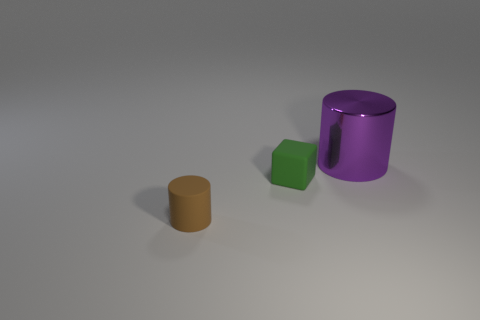Are there any other things that are the same shape as the tiny green rubber object?
Ensure brevity in your answer.  No. What shape is the shiny object that is on the right side of the matte object that is in front of the small object that is behind the rubber cylinder?
Your response must be concise. Cylinder. What is the color of the cylinder in front of the big metal thing?
Offer a terse response. Brown. How many things are objects behind the brown cylinder or cylinders right of the small cube?
Your response must be concise. 2. What number of shiny objects are the same shape as the small brown matte thing?
Your answer should be very brief. 1. There is a cube that is the same size as the matte cylinder; what color is it?
Your response must be concise. Green. The cylinder behind the matte thing to the left of the green matte thing right of the tiny cylinder is what color?
Offer a very short reply. Purple. Is the size of the green matte cube the same as the purple cylinder behind the small green matte cube?
Keep it short and to the point. No. What number of objects are brown shiny cylinders or brown objects?
Ensure brevity in your answer.  1. Is there a cube that has the same material as the green thing?
Ensure brevity in your answer.  No. 